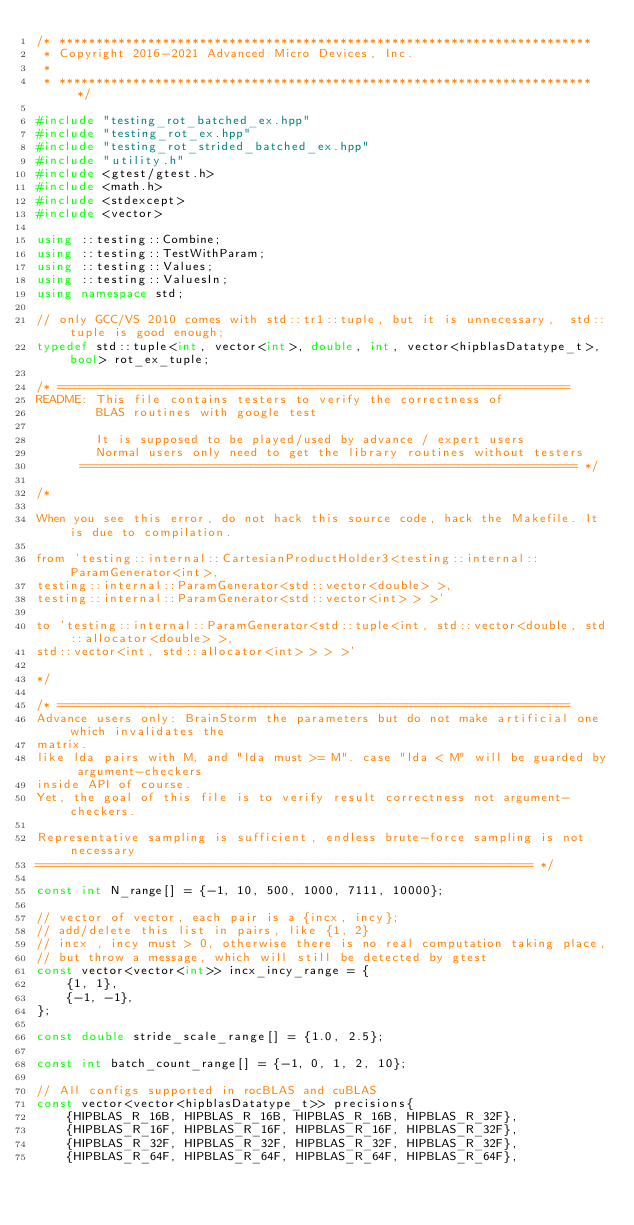Convert code to text. <code><loc_0><loc_0><loc_500><loc_500><_C++_>/* ************************************************************************
 * Copyright 2016-2021 Advanced Micro Devices, Inc.
 *
 * ************************************************************************ */

#include "testing_rot_batched_ex.hpp"
#include "testing_rot_ex.hpp"
#include "testing_rot_strided_batched_ex.hpp"
#include "utility.h"
#include <gtest/gtest.h>
#include <math.h>
#include <stdexcept>
#include <vector>

using ::testing::Combine;
using ::testing::TestWithParam;
using ::testing::Values;
using ::testing::ValuesIn;
using namespace std;

// only GCC/VS 2010 comes with std::tr1::tuple, but it is unnecessary,  std::tuple is good enough;
typedef std::tuple<int, vector<int>, double, int, vector<hipblasDatatype_t>, bool> rot_ex_tuple;

/* =====================================================================
README: This file contains testers to verify the correctness of
        BLAS routines with google test

        It is supposed to be played/used by advance / expert users
        Normal users only need to get the library routines without testers
      =================================================================== */

/*

When you see this error, do not hack this source code, hack the Makefile. It is due to compilation.

from 'testing::internal::CartesianProductHolder3<testing::internal::ParamGenerator<int>,
testing::internal::ParamGenerator<std::vector<double> >,
testing::internal::ParamGenerator<std::vector<int> > >'

to 'testing::internal::ParamGenerator<std::tuple<int, std::vector<double, std::allocator<double> >,
std::vector<int, std::allocator<int> > > >'

*/

/* =====================================================================
Advance users only: BrainStorm the parameters but do not make artificial one which invalidates the
matrix.
like lda pairs with M, and "lda must >= M". case "lda < M" will be guarded by argument-checkers
inside API of course.
Yet, the goal of this file is to verify result correctness not argument-checkers.

Representative sampling is sufficient, endless brute-force sampling is not necessary
=================================================================== */

const int N_range[] = {-1, 10, 500, 1000, 7111, 10000};

// vector of vector, each pair is a {incx, incy};
// add/delete this list in pairs, like {1, 2}
// incx , incy must > 0, otherwise there is no real computation taking place,
// but throw a message, which will still be detected by gtest
const vector<vector<int>> incx_incy_range = {
    {1, 1},
    {-1, -1},
};

const double stride_scale_range[] = {1.0, 2.5};

const int batch_count_range[] = {-1, 0, 1, 2, 10};

// All configs supported in rocBLAS and cuBLAS
const vector<vector<hipblasDatatype_t>> precisions{
    {HIPBLAS_R_16B, HIPBLAS_R_16B, HIPBLAS_R_16B, HIPBLAS_R_32F},
    {HIPBLAS_R_16F, HIPBLAS_R_16F, HIPBLAS_R_16F, HIPBLAS_R_32F},
    {HIPBLAS_R_32F, HIPBLAS_R_32F, HIPBLAS_R_32F, HIPBLAS_R_32F},
    {HIPBLAS_R_64F, HIPBLAS_R_64F, HIPBLAS_R_64F, HIPBLAS_R_64F},</code> 